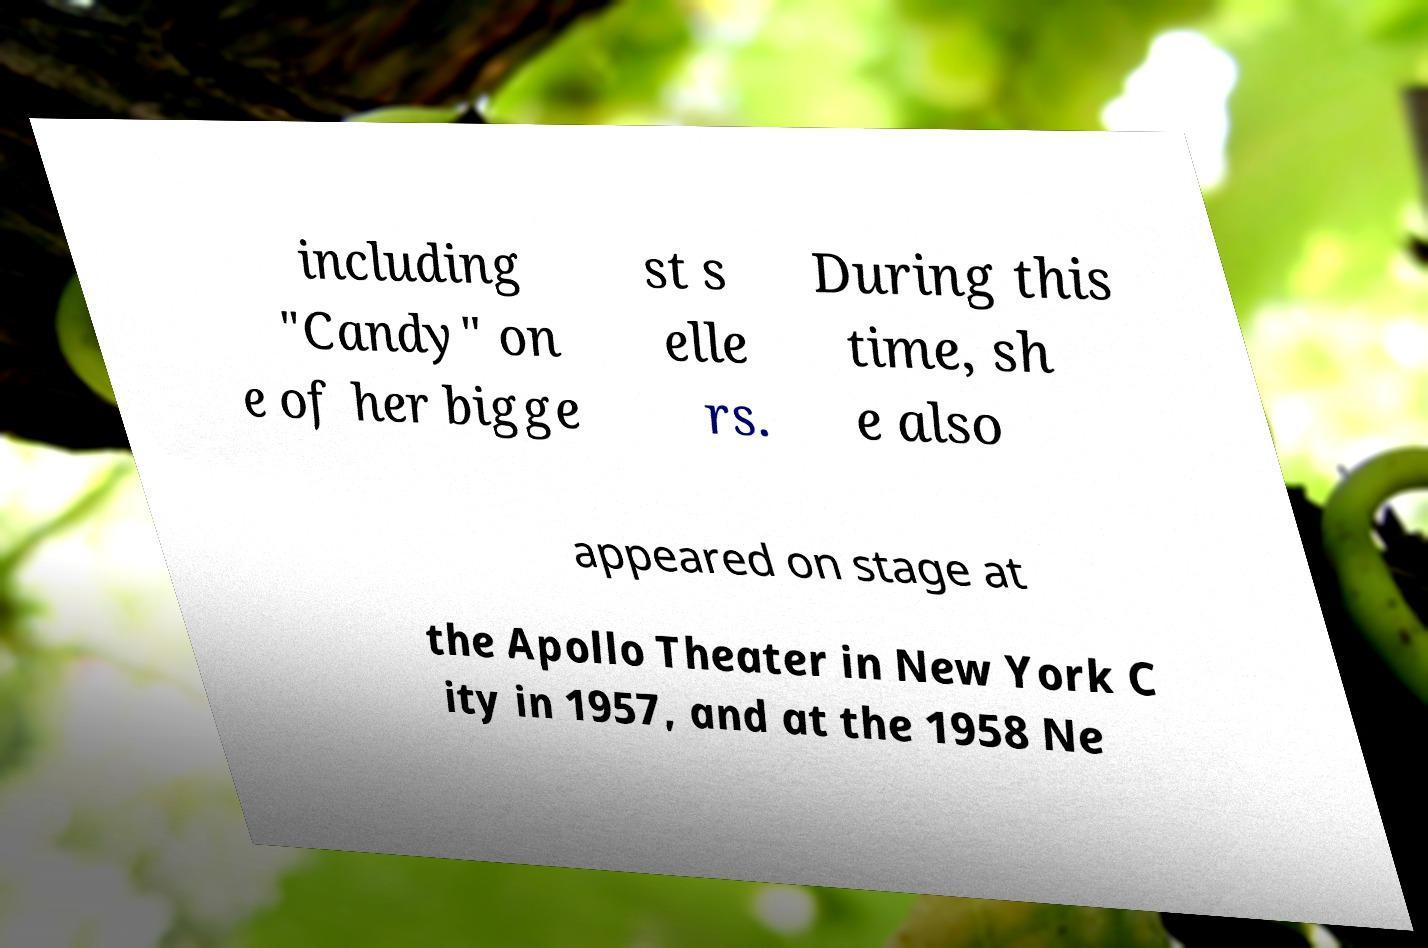What messages or text are displayed in this image? I need them in a readable, typed format. including "Candy" on e of her bigge st s elle rs. During this time, sh e also appeared on stage at the Apollo Theater in New York C ity in 1957, and at the 1958 Ne 